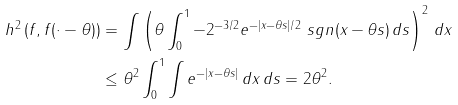Convert formula to latex. <formula><loc_0><loc_0><loc_500><loc_500>h ^ { 2 } \left ( f , f ( \cdot - \theta ) \right ) & = \int \left ( \theta \int _ { 0 } ^ { 1 } - 2 ^ { - 3 / 2 } e ^ { - | x - \theta s | / 2 } \ s g n ( x - \theta s ) \, d s \right ) ^ { 2 } \, d x \\ & \leq \theta ^ { 2 } \int _ { 0 } ^ { 1 } \int e ^ { - | x - \theta s | } \, d x \, d s = 2 \theta ^ { 2 } .</formula> 